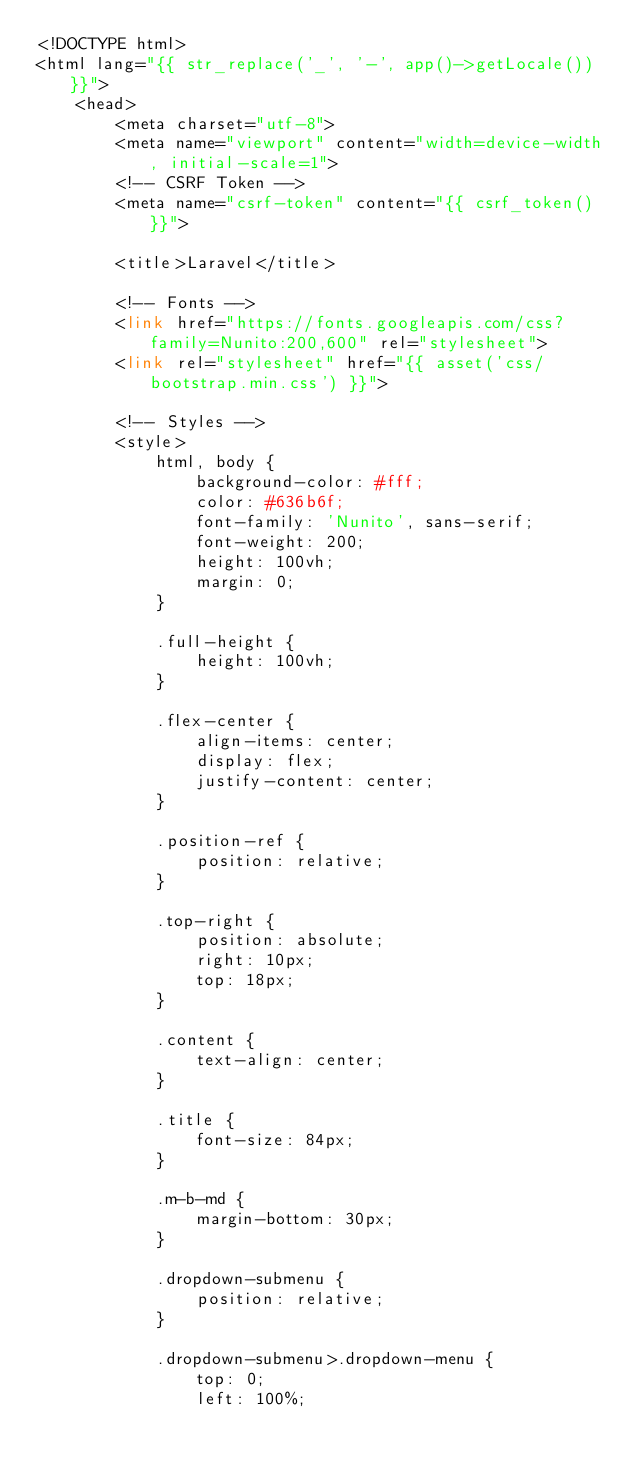<code> <loc_0><loc_0><loc_500><loc_500><_PHP_><!DOCTYPE html>
<html lang="{{ str_replace('_', '-', app()->getLocale()) }}">
    <head>
        <meta charset="utf-8">
        <meta name="viewport" content="width=device-width, initial-scale=1">
        <!-- CSRF Token -->
        <meta name="csrf-token" content="{{ csrf_token() }}">

        <title>Laravel</title>

        <!-- Fonts -->
        <link href="https://fonts.googleapis.com/css?family=Nunito:200,600" rel="stylesheet">
        <link rel="stylesheet" href="{{ asset('css/bootstrap.min.css') }}">

        <!-- Styles -->
        <style>
            html, body {
                background-color: #fff;
                color: #636b6f;
                font-family: 'Nunito', sans-serif;
                font-weight: 200;
                height: 100vh;
                margin: 0;
            }

            .full-height {
                height: 100vh;
            }

            .flex-center {
                align-items: center;
                display: flex;
                justify-content: center;
            }

            .position-ref {
                position: relative;
            }

            .top-right {
                position: absolute;
                right: 10px;
                top: 18px;
            }

            .content {
                text-align: center;
            }

            .title {
                font-size: 84px;
            }

            .m-b-md {
                margin-bottom: 30px;
            }

            .dropdown-submenu {
                position: relative;
            }

            .dropdown-submenu>.dropdown-menu {
                top: 0;
                left: 100%;</code> 